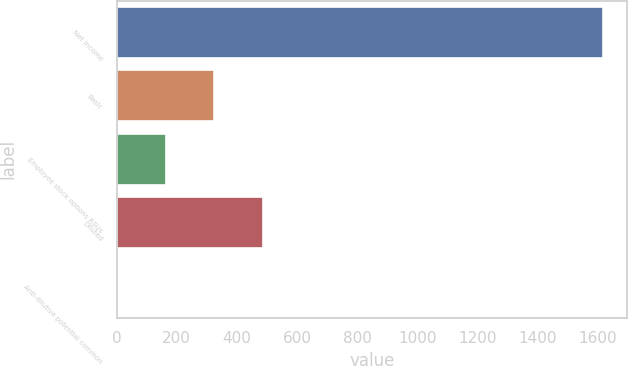<chart> <loc_0><loc_0><loc_500><loc_500><bar_chart><fcel>Net income<fcel>Basic<fcel>Employee stock options RSUs<fcel>Diluted<fcel>Anti-dilutive potential common<nl><fcel>1617<fcel>325<fcel>163.5<fcel>486.5<fcel>2<nl></chart> 